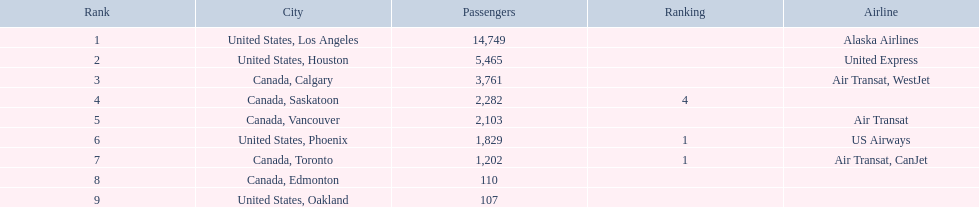What numbers are in the passengers column? 14,749, 5,465, 3,761, 2,282, 2,103, 1,829, 1,202, 110, 107. Which number is the lowest number in the passengers column? 107. What city is associated with this number? United States, Oakland. What are the cities flown to? United States, Los Angeles, United States, Houston, Canada, Calgary, Canada, Saskatoon, Canada, Vancouver, United States, Phoenix, Canada, Toronto, Canada, Edmonton, United States, Oakland. What number of passengers did pheonix have? 1,829. 